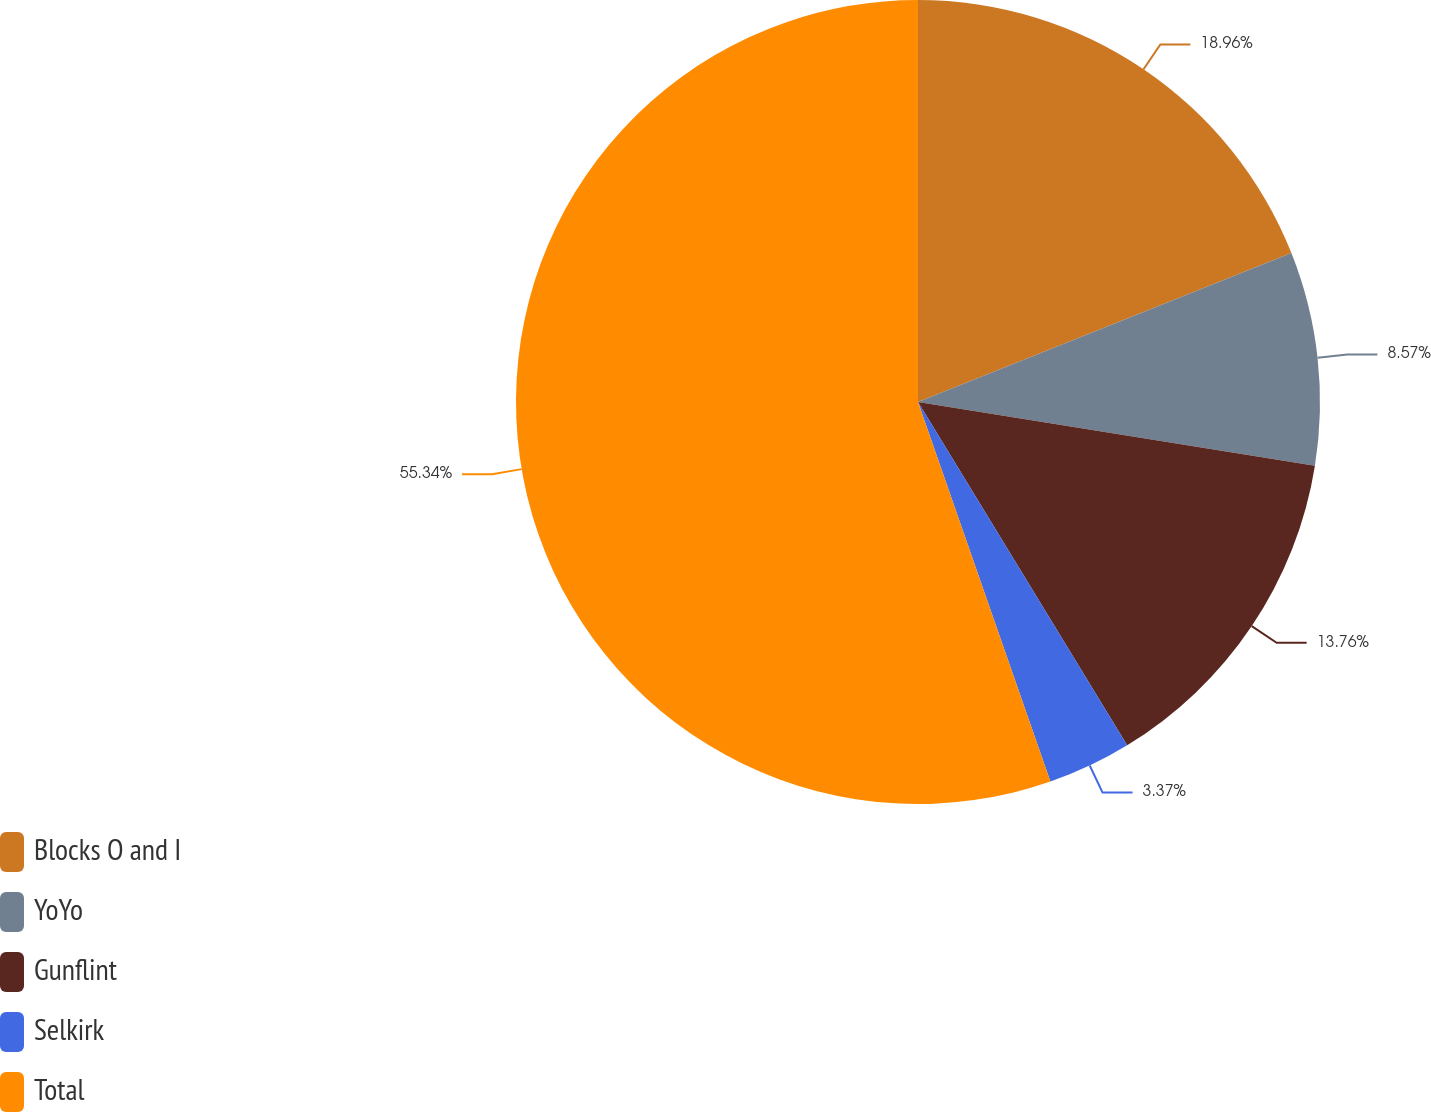Convert chart to OTSL. <chart><loc_0><loc_0><loc_500><loc_500><pie_chart><fcel>Blocks O and I<fcel>YoYo<fcel>Gunflint<fcel>Selkirk<fcel>Total<nl><fcel>18.96%<fcel>8.57%<fcel>13.76%<fcel>3.37%<fcel>55.34%<nl></chart> 